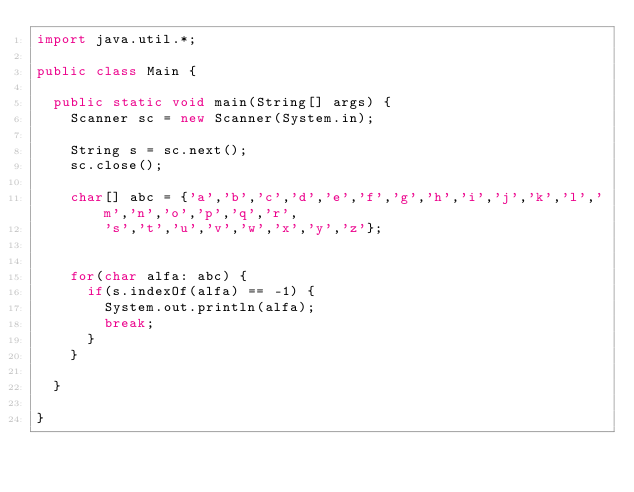Convert code to text. <code><loc_0><loc_0><loc_500><loc_500><_Java_>import java.util.*;

public class Main {

	public static void main(String[] args) {
		Scanner sc = new Scanner(System.in);
		
		String s = sc.next();
		sc.close();
		
		char[] abc = {'a','b','c','d','e','f','g','h','i','j','k','l','m','n','o','p','q','r',
				's','t','u','v','w','x','y','z'};
		
		
		for(char alfa: abc) {
			if(s.indexOf(alfa) == -1) {
				System.out.println(alfa);
				break;
			}
		}

	}

}
</code> 